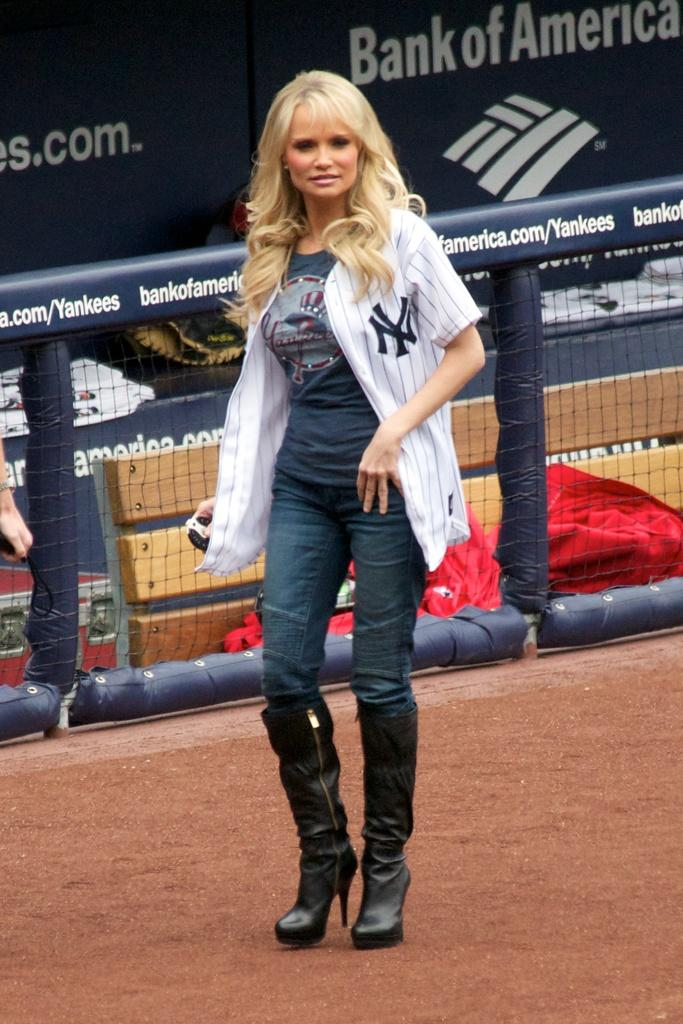<image>
Summarize the visual content of the image. The lady with NY on her top may be a new york yankees supporter. 